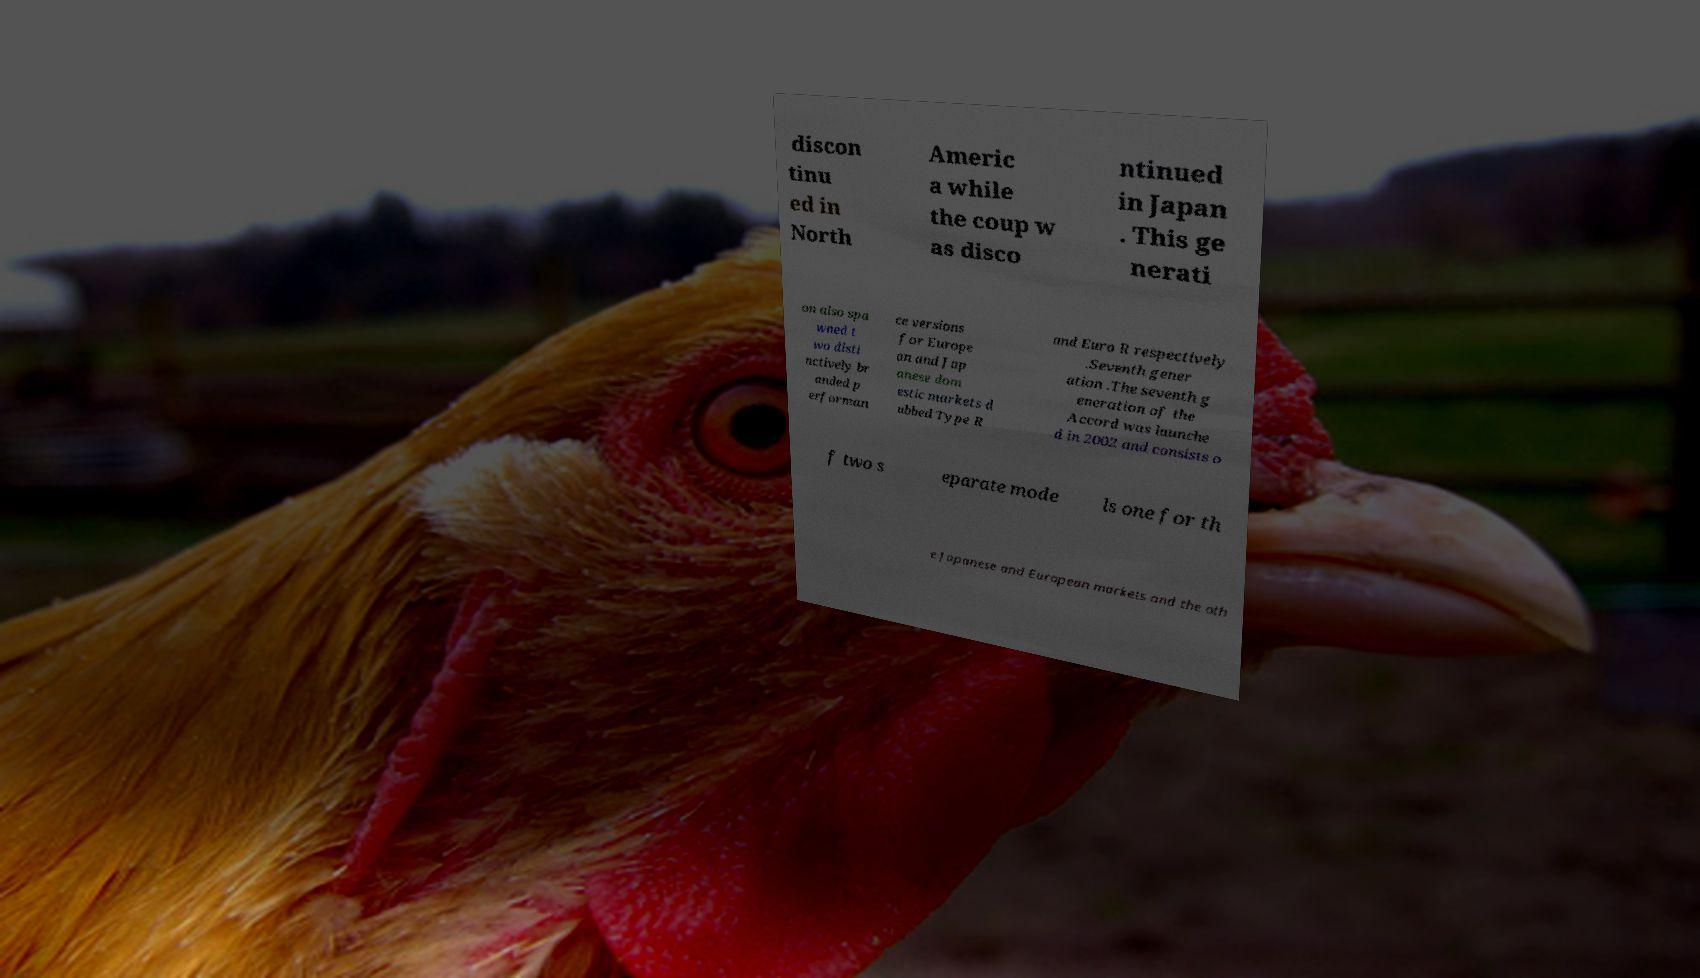Could you extract and type out the text from this image? discon tinu ed in North Americ a while the coup w as disco ntinued in Japan . This ge nerati on also spa wned t wo disti nctively br anded p erforman ce versions for Europe an and Jap anese dom estic markets d ubbed Type R and Euro R respectively .Seventh gener ation .The seventh g eneration of the Accord was launche d in 2002 and consists o f two s eparate mode ls one for th e Japanese and European markets and the oth 